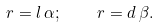Convert formula to latex. <formula><loc_0><loc_0><loc_500><loc_500>r = l \, \alpha ; \quad r = d \, \beta .</formula> 